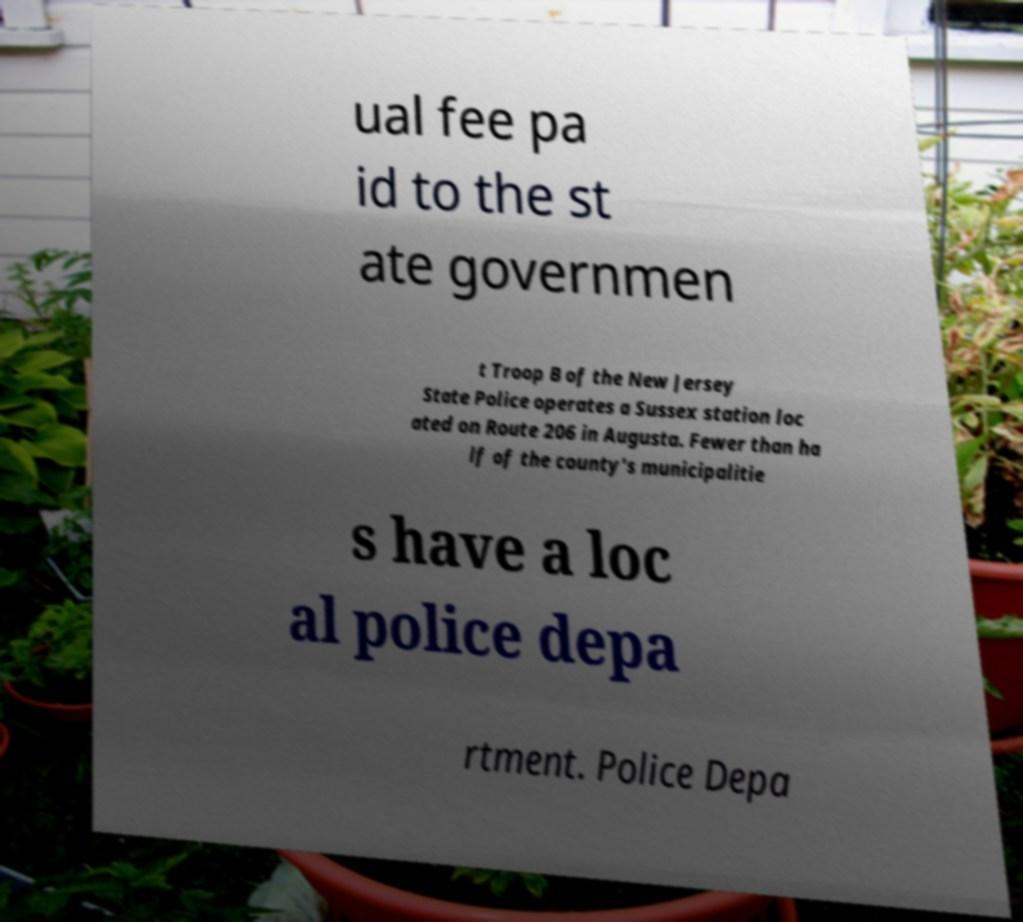Could you extract and type out the text from this image? ual fee pa id to the st ate governmen t Troop B of the New Jersey State Police operates a Sussex station loc ated on Route 206 in Augusta. Fewer than ha lf of the county's municipalitie s have a loc al police depa rtment. Police Depa 